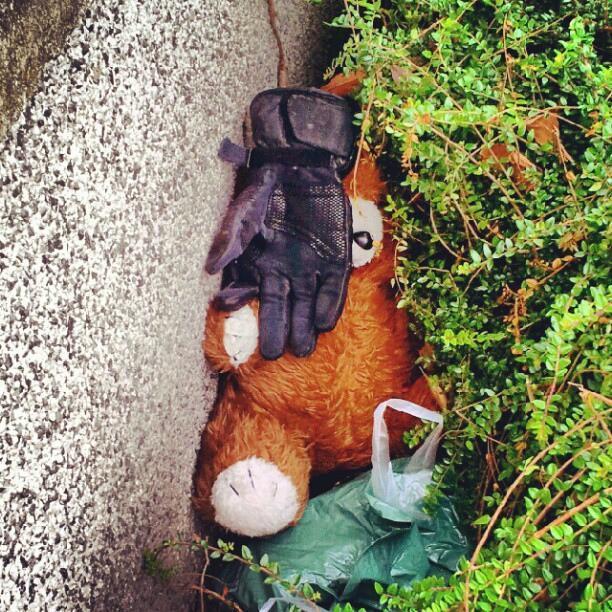How many bus riders are leaning out of a bus window?
Give a very brief answer. 0. 